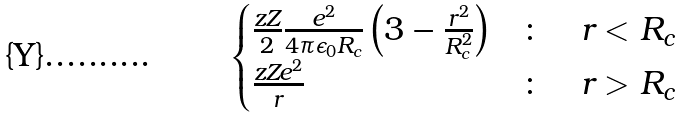Convert formula to latex. <formula><loc_0><loc_0><loc_500><loc_500>\begin{cases} \frac { z Z } { 2 } \frac { e ^ { 2 } } { 4 { \pi } { \epsilon _ { 0 } } R _ { c } } \left ( 3 - \frac { r ^ { 2 } } { R _ { c } ^ { 2 } } \right ) & \colon \quad r < R _ { c } \\ \frac { z Z e ^ { 2 } } { r } & \colon \quad r > R _ { c } \end{cases}</formula> 